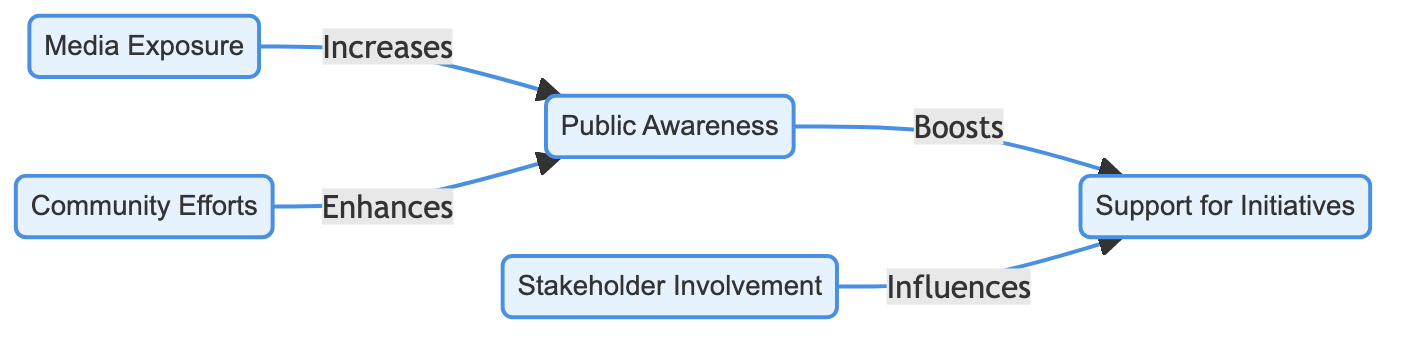What are the nodes present in the diagram? The diagram consists of five nodes: Media Exposure, Public Awareness, Support for Initiatives, Community Efforts, and Stakeholder Involvement.
Answer: Media Exposure, Public Awareness, Support for Initiatives, Community Efforts, Stakeholder Involvement How many edges are there in the diagram? The diagram has four edges showing the relationships between the nodes: Media Exposure to Public Awareness, Public Awareness to Support for Initiatives, Community Efforts to Public Awareness, and Stakeholder Involvement to Support for Initiatives.
Answer: 4 What does Media Exposure increase? According to the diagram, Media Exposure increases Public Awareness.
Answer: Public Awareness Which node enhances Public Awareness? Community Efforts are shown to enhance Public Awareness in the diagram.
Answer: Community Efforts How does Public Awareness influence Support for Initiatives? The diagram indicates that Public Awareness boosts Support for Initiatives, demonstrating a direct positive influence.
Answer: Boosts What influences Support for Initiatives according to the diagram? Stakeholder Involvement is indicated to influence Support for Initiatives within the flow of the diagram.
Answer: Stakeholder Involvement If Media Exposure is increased, what effect does it have on Support for Initiatives? Media Exposure increases Public Awareness, which subsequently boosts Support for Initiatives, creating an indirect positive influence on it.
Answer: Indirectly increases Which two nodes have a direct relationship, and what is that relationship? The direct relationship exists between Public Awareness and Support for Initiatives, where Public Awareness boosts Support for Initiatives.
Answer: Boosts What type of diagram is displayed? The diagram is a Social Science Diagram that analyzes community perception regarding coral reef restoration initiatives.
Answer: Social Science Diagram 